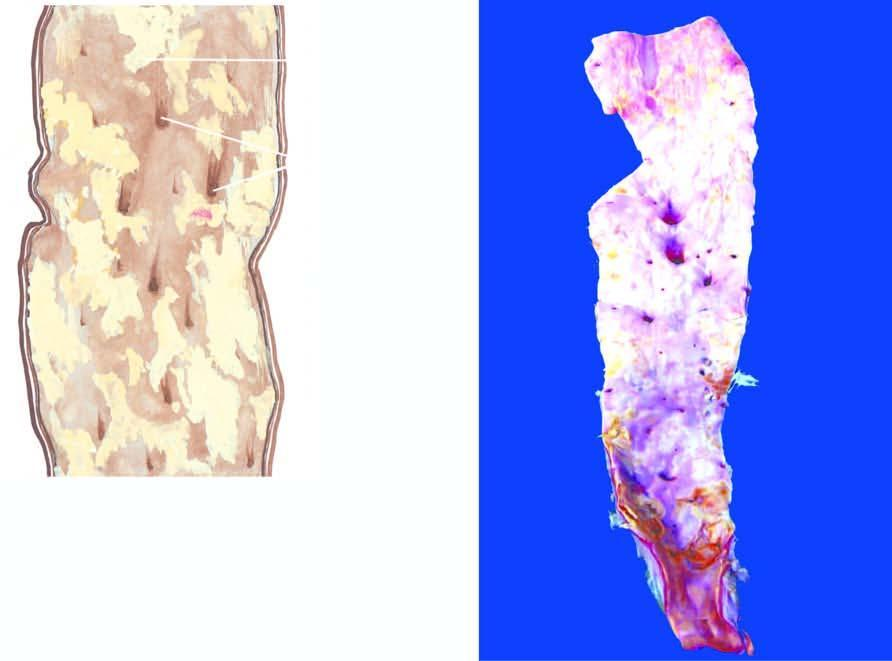do the shift of the curve to higher oxygen delivery have ulcerated surface?
Answer the question using a single word or phrase. No 